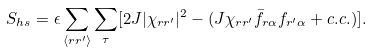<formula> <loc_0><loc_0><loc_500><loc_500>S _ { h s } = \epsilon \sum _ { \langle r r ^ { \prime } \rangle } \sum _ { \tau } [ 2 J | \chi _ { r r ^ { \prime } } | ^ { 2 } - ( J \chi _ { r r ^ { \prime } } \bar { f } _ { r \alpha } f _ { r ^ { \prime } \alpha } + c . c . ) ] .</formula> 